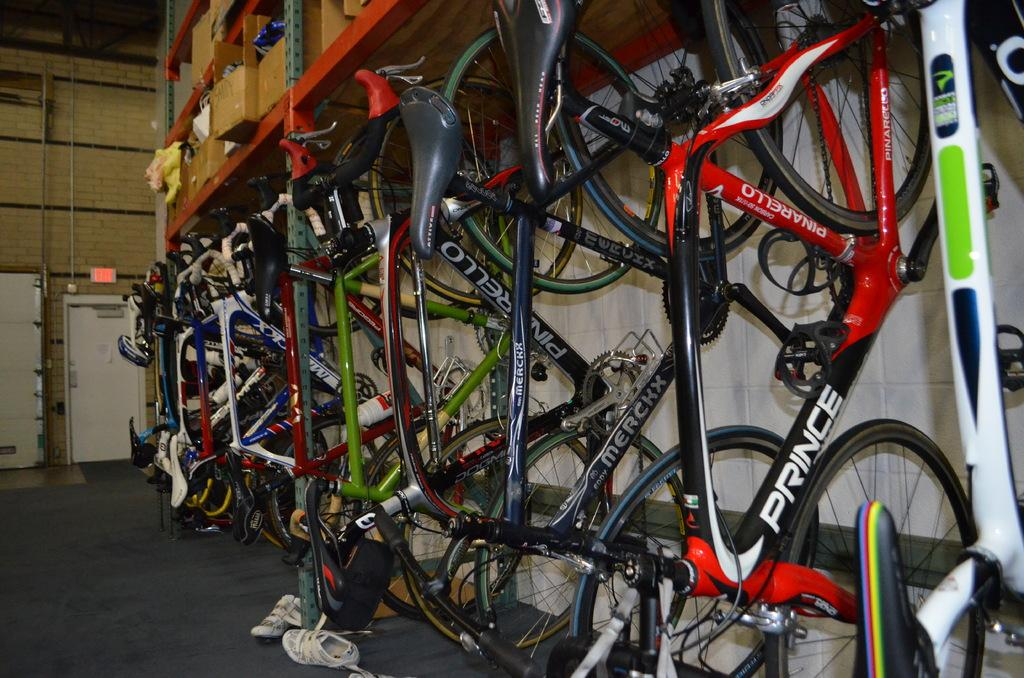What can be seen on the rack in the image? There are bicycles on a rack in the image. What is located on the left side of the image? There are two doors to a wall on the left side of the image. What type of footwear is visible at the bottom of the image? There are shoes at the bottom of the image. How much wealth does the grandfather possess in the image? There is no mention of a grandfather or wealth in the image; it only features bicycles on a rack, two doors to a wall, and shoes. 